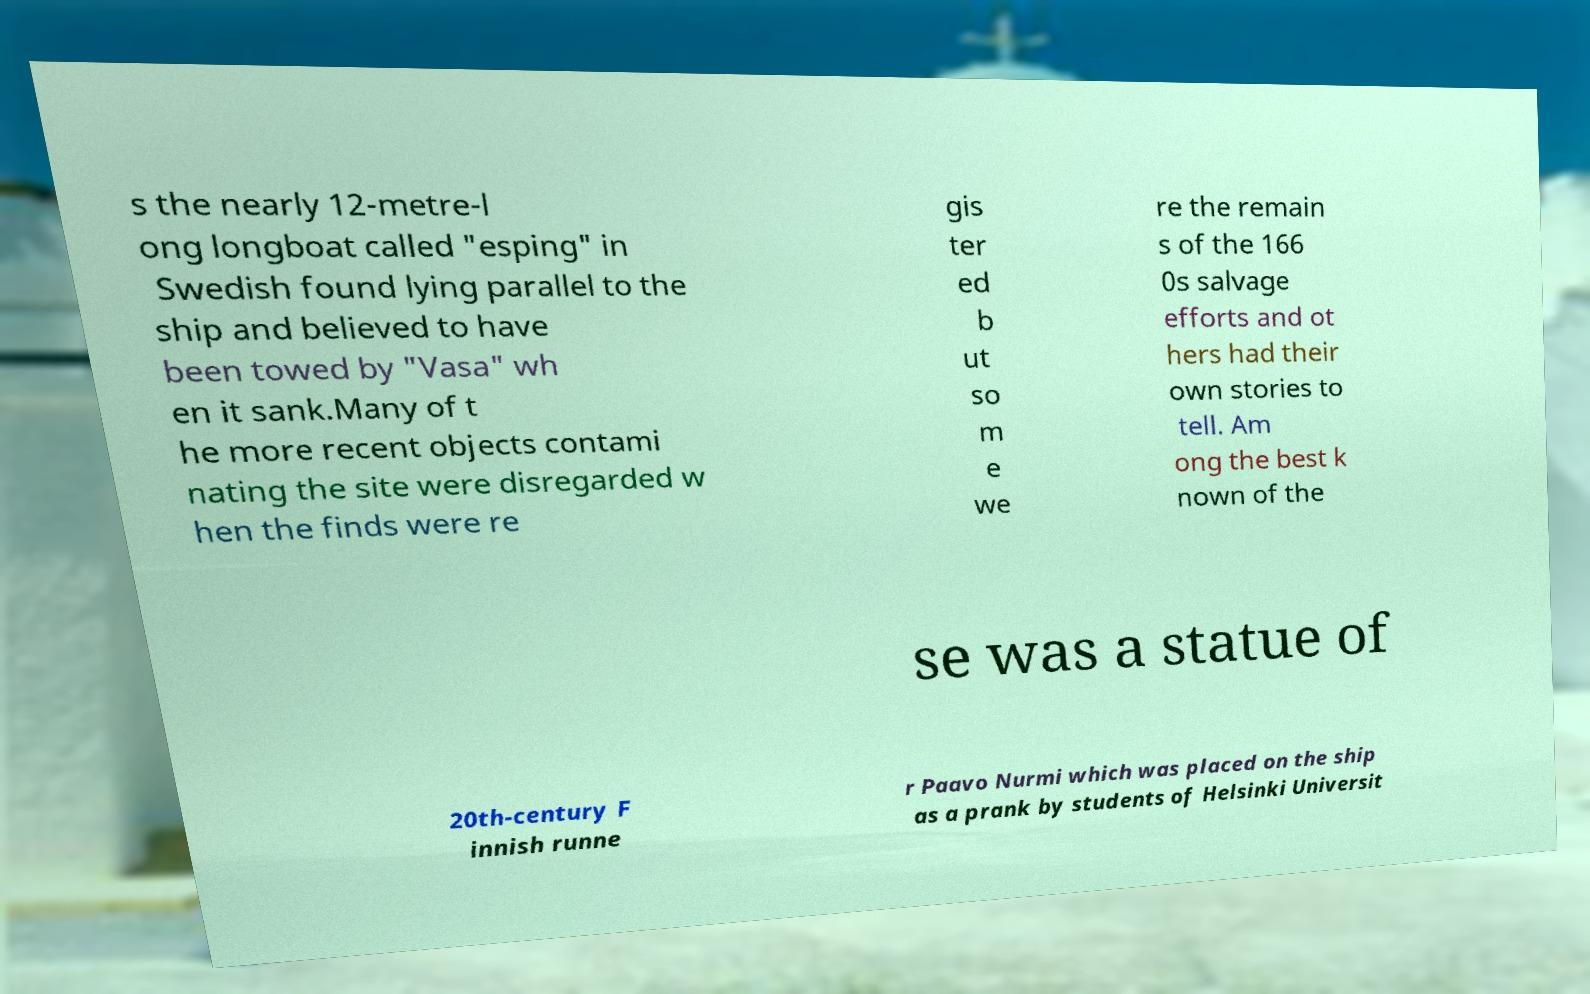Could you extract and type out the text from this image? s the nearly 12-metre-l ong longboat called "esping" in Swedish found lying parallel to the ship and believed to have been towed by "Vasa" wh en it sank.Many of t he more recent objects contami nating the site were disregarded w hen the finds were re gis ter ed b ut so m e we re the remain s of the 166 0s salvage efforts and ot hers had their own stories to tell. Am ong the best k nown of the se was a statue of 20th-century F innish runne r Paavo Nurmi which was placed on the ship as a prank by students of Helsinki Universit 